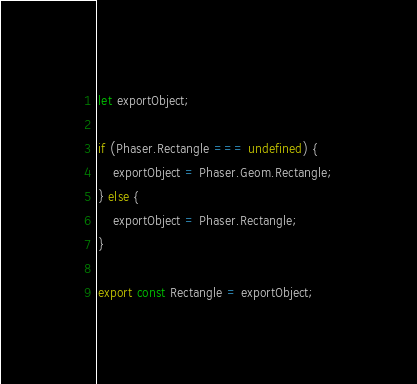Convert code to text. <code><loc_0><loc_0><loc_500><loc_500><_JavaScript_>let exportObject;

if (Phaser.Rectangle === undefined) {
    exportObject = Phaser.Geom.Rectangle;
} else {
    exportObject = Phaser.Rectangle;
}

export const Rectangle = exportObject;
</code> 